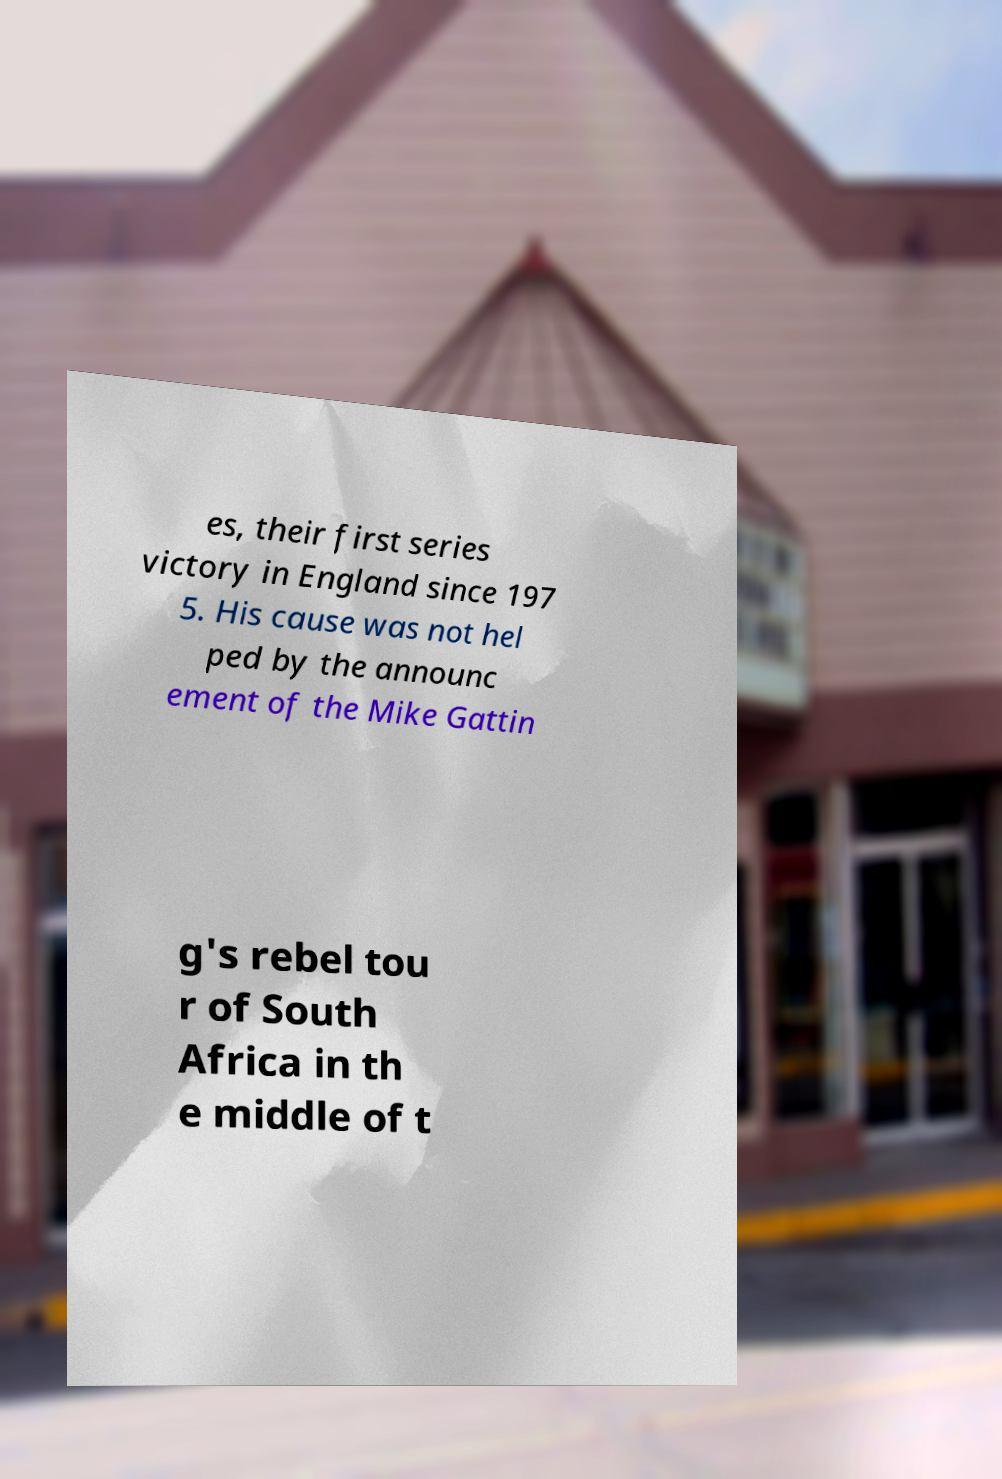Please read and relay the text visible in this image. What does it say? es, their first series victory in England since 197 5. His cause was not hel ped by the announc ement of the Mike Gattin g's rebel tou r of South Africa in th e middle of t 